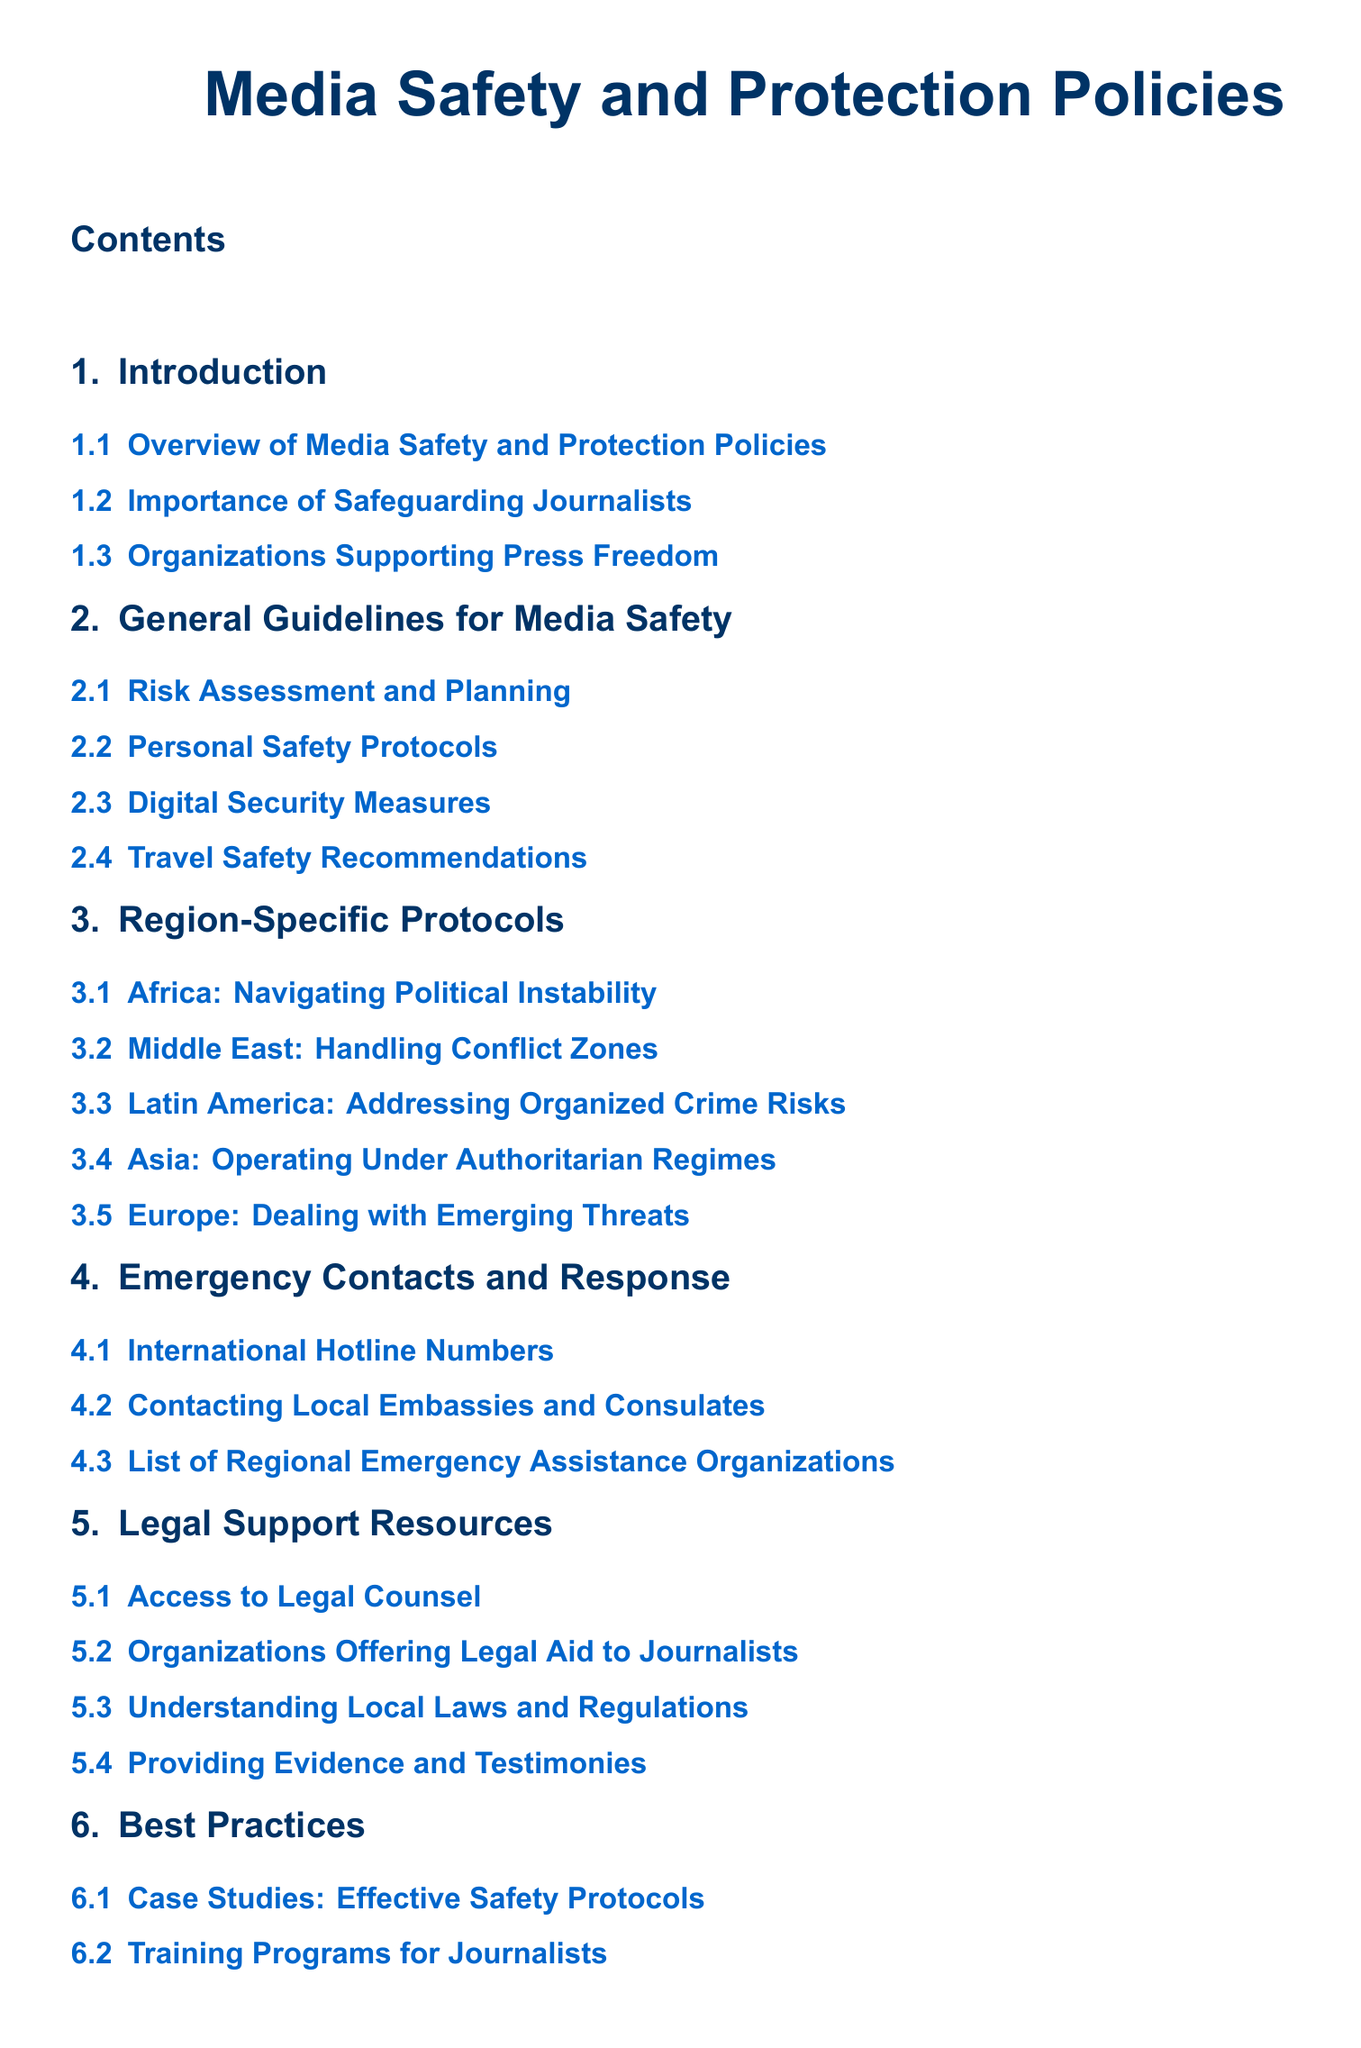What is the title of the document? The title is located at the top of the document, highlighting the focus on media safety and protection policies.
Answer: Media Safety and Protection Policies How many sections are in this document? The number of sections is listed directly in the table of contents, which includes eight main sections.
Answer: 8 What region-specific protocols are mentioned for Africa? The table of contents indicates that there is a protocol specifically addressing the conditions in Africa.
Answer: Navigating Political Instability Which organization type is included in the section about legal support resources? The document describes various types of organizations that provide legal aid, which are explicitly mentioned in the table of contents.
Answer: Organizations Offering Legal Aid to Journalists What is one of the best practices highlighted in the document? The table of contents lists best practices that are derived from effective case studies and training approaches for journalists.
Answer: Case Studies: Effective Safety Protocols Which section covers emergency contact information? This information is best retrieved from the structured sections of the document that focus on safety and emergency measures.
Answer: Emergency Contacts and Response What is the last subsection listed in the document? The last subsection provides additional clarifications about terms used throughout the document and can be found in the appendix.
Answer: Acronyms What is emphasized in the conclusion of the document? The conclusion summarizes key themes and thoughts related to the topic of press freedom and media safety, making it a critical section.
Answer: Encouraging Collaborative Efforts 